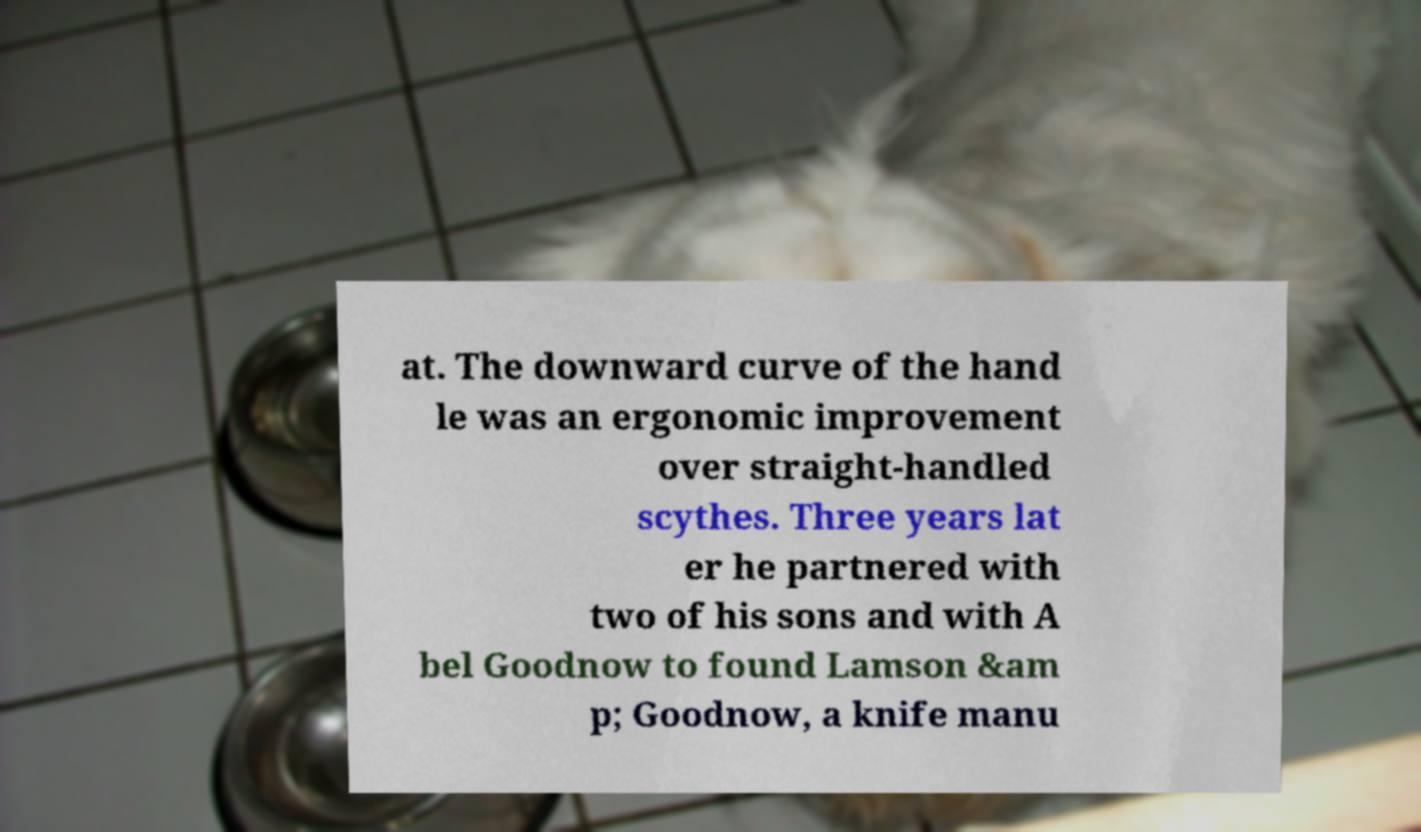Please identify and transcribe the text found in this image. at. The downward curve of the hand le was an ergonomic improvement over straight-handled scythes. Three years lat er he partnered with two of his sons and with A bel Goodnow to found Lamson &am p; Goodnow, a knife manu 